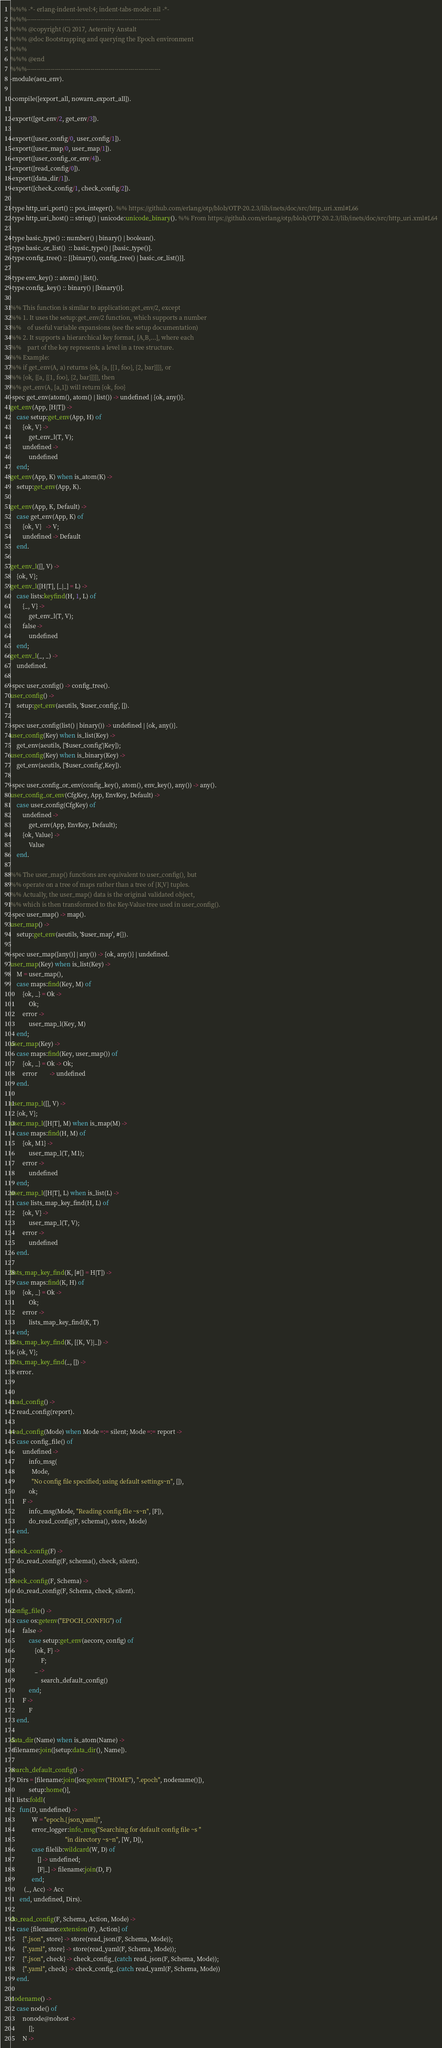<code> <loc_0><loc_0><loc_500><loc_500><_Erlang_>%%% -*- erlang-indent-level:4; indent-tabs-mode: nil -*-
%%%-------------------------------------------------------------------
%%% @copyright (C) 2017, Aeternity Anstalt
%%% @doc Bootstrapping and querying the Epoch environment
%%%
%%% @end
%%%-------------------------------------------------------------------
-module(aeu_env).

-compile([export_all, nowarn_export_all]).

-export([get_env/2, get_env/3]).

-export([user_config/0, user_config/1]).
-export([user_map/0, user_map/1]).
-export([user_config_or_env/4]).
-export([read_config/0]).
-export([data_dir/1]).
-export([check_config/1, check_config/2]).

-type http_uri_port() :: pos_integer(). %% https://github.com/erlang/otp/blob/OTP-20.2.3/lib/inets/doc/src/http_uri.xml#L66
-type http_uri_host() :: string() | unicode:unicode_binary(). %% From https://github.com/erlang/otp/blob/OTP-20.2.3/lib/inets/doc/src/http_uri.xml#L64

-type basic_type() :: number() | binary() | boolean().
-type basic_or_list()  :: basic_type() | [basic_type()].
-type config_tree() :: [{binary(), config_tree() | basic_or_list()}].

-type env_key() :: atom() | list().
-type config_key() :: binary() | [binary()].

%% This function is similar to application:get_env/2, except
%% 1. It uses the setup:get_env/2 function, which supports a number
%%    of useful variable expansions (see the setup documentation)
%% 2. It supports a hierarchical key format, [A,B,...], where each
%%    part of the key represents a level in a tree structure.
%% Example:
%% if get_env(A, a) returns {ok, {a, [{1, foo}, {2, bar}]}}, or
%% {ok, [{a, [{1, foo}, {2, bar}]}]}, then
%% get_env(A, [a,1]) will return {ok, foo}
-spec get_env(atom(), atom() | list()) -> undefined | {ok, any()}.
get_env(App, [H|T]) ->
    case setup:get_env(App, H) of
        {ok, V} ->
            get_env_l(T, V);
        undefined ->
            undefined
    end;
get_env(App, K) when is_atom(K) ->
    setup:get_env(App, K).

get_env(App, K, Default) ->
    case get_env(App, K) of
        {ok, V}   -> V;
        undefined -> Default
    end.

get_env_l([], V) ->
    {ok, V};
get_env_l([H|T], [_|_] = L) ->
    case lists:keyfind(H, 1, L) of
        {_, V} ->
            get_env_l(T, V);
        false ->
            undefined
    end;
get_env_l(_, _) ->
    undefined.

-spec user_config() -> config_tree().
user_config() ->
    setup:get_env(aeutils, '$user_config', []).

-spec user_config(list() | binary()) -> undefined | {ok, any()}.
user_config(Key) when is_list(Key) ->
    get_env(aeutils, ['$user_config'|Key]);
user_config(Key) when is_binary(Key) ->
    get_env(aeutils, ['$user_config',Key]).

-spec user_config_or_env(config_key(), atom(), env_key(), any()) -> any().
user_config_or_env(CfgKey, App, EnvKey, Default) ->
    case user_config(CfgKey) of
        undefined ->
            get_env(App, EnvKey, Default);
        {ok, Value} ->
            Value
    end.

%% The user_map() functions are equivalent to user_config(), but
%% operate on a tree of maps rather than a tree of {K,V} tuples.
%% Actually, the user_map() data is the original validated object,
%% which is then transformed to the Key-Value tree used in user_config().
-spec user_map() -> map().
user_map() ->
    setup:get_env(aeutils, '$user_map', #{}).

-spec user_map([any()] | any()) -> {ok, any()} | undefined.
user_map(Key) when is_list(Key) ->
    M = user_map(),
    case maps:find(Key, M) of
        {ok, _} = Ok ->
            Ok;
        error ->
            user_map_l(Key, M)
    end;
user_map(Key) ->
    case maps:find(Key, user_map()) of
        {ok, _} = Ok -> Ok;
        error        -> undefined
    end.

user_map_l([], V) ->
    {ok, V};
user_map_l([H|T], M) when is_map(M) ->
    case maps:find(H, M) of
        {ok, M1} ->
            user_map_l(T, M1);
        error ->
            undefined
    end;
user_map_l([H|T], L) when is_list(L) ->
    case lists_map_key_find(H, L) of
        {ok, V} ->
            user_map_l(T, V);
        error ->
            undefined
    end.

lists_map_key_find(K, [#{} = H|T]) ->
    case maps:find(K, H) of
        {ok, _} = Ok ->
            Ok;
        error ->
            lists_map_key_find(K, T)
    end;
lists_map_key_find(K, [{K, V}|_]) ->
    {ok, V};
lists_map_key_find(_, []) ->
    error.


read_config() ->
    read_config(report).

read_config(Mode) when Mode =:= silent; Mode =:= report ->
    case config_file() of
        undefined ->
            info_msg(
              Mode,
              "No config file specified; using default settings~n", []),
            ok;
        F ->
            info_msg(Mode, "Reading config file ~s~n", [F]),
            do_read_config(F, schema(), store, Mode)
    end.

check_config(F) ->
    do_read_config(F, schema(), check, silent).

check_config(F, Schema) ->
    do_read_config(F, Schema, check, silent).

config_file() ->
    case os:getenv("EPOCH_CONFIG") of
        false ->
            case setup:get_env(aecore, config) of
                {ok, F} ->
                    F;
                _ ->
                    search_default_config()
            end;
        F ->
            F
    end.

data_dir(Name) when is_atom(Name) ->
  filename:join([setup:data_dir(), Name]).

search_default_config() ->
    Dirs = [filename:join([os:getenv("HOME"), ".epoch", nodename()]),
            setup:home()],
    lists:foldl(
      fun(D, undefined) ->
              W = "epoch.{json,yaml}",
              error_logger:info_msg("Searching for default config file ~s "
                                    "in directory ~s~n", [W, D]),
              case filelib:wildcard(W, D) of
                  [] -> undefined;
                  [F|_] -> filename:join(D, F)
              end;
         (_, Acc) -> Acc
      end, undefined, Dirs).

do_read_config(F, Schema, Action, Mode) ->
    case {filename:extension(F), Action} of
        {".json", store} -> store(read_json(F, Schema, Mode));
        {".yaml", store} -> store(read_yaml(F, Schema, Mode));
        {".json", check} -> check_config_(catch read_json(F, Schema, Mode));
        {".yaml", check} -> check_config_(catch read_yaml(F, Schema, Mode))
    end.

nodename() ->
    case node() of
        nonode@nohost ->
            [];
        N -></code> 